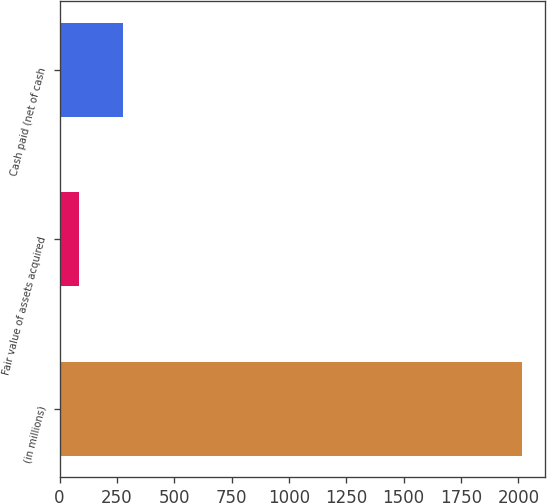Convert chart. <chart><loc_0><loc_0><loc_500><loc_500><bar_chart><fcel>(in millions)<fcel>Fair value of assets acquired<fcel>Cash paid (net of cash<nl><fcel>2017<fcel>83<fcel>276.4<nl></chart> 